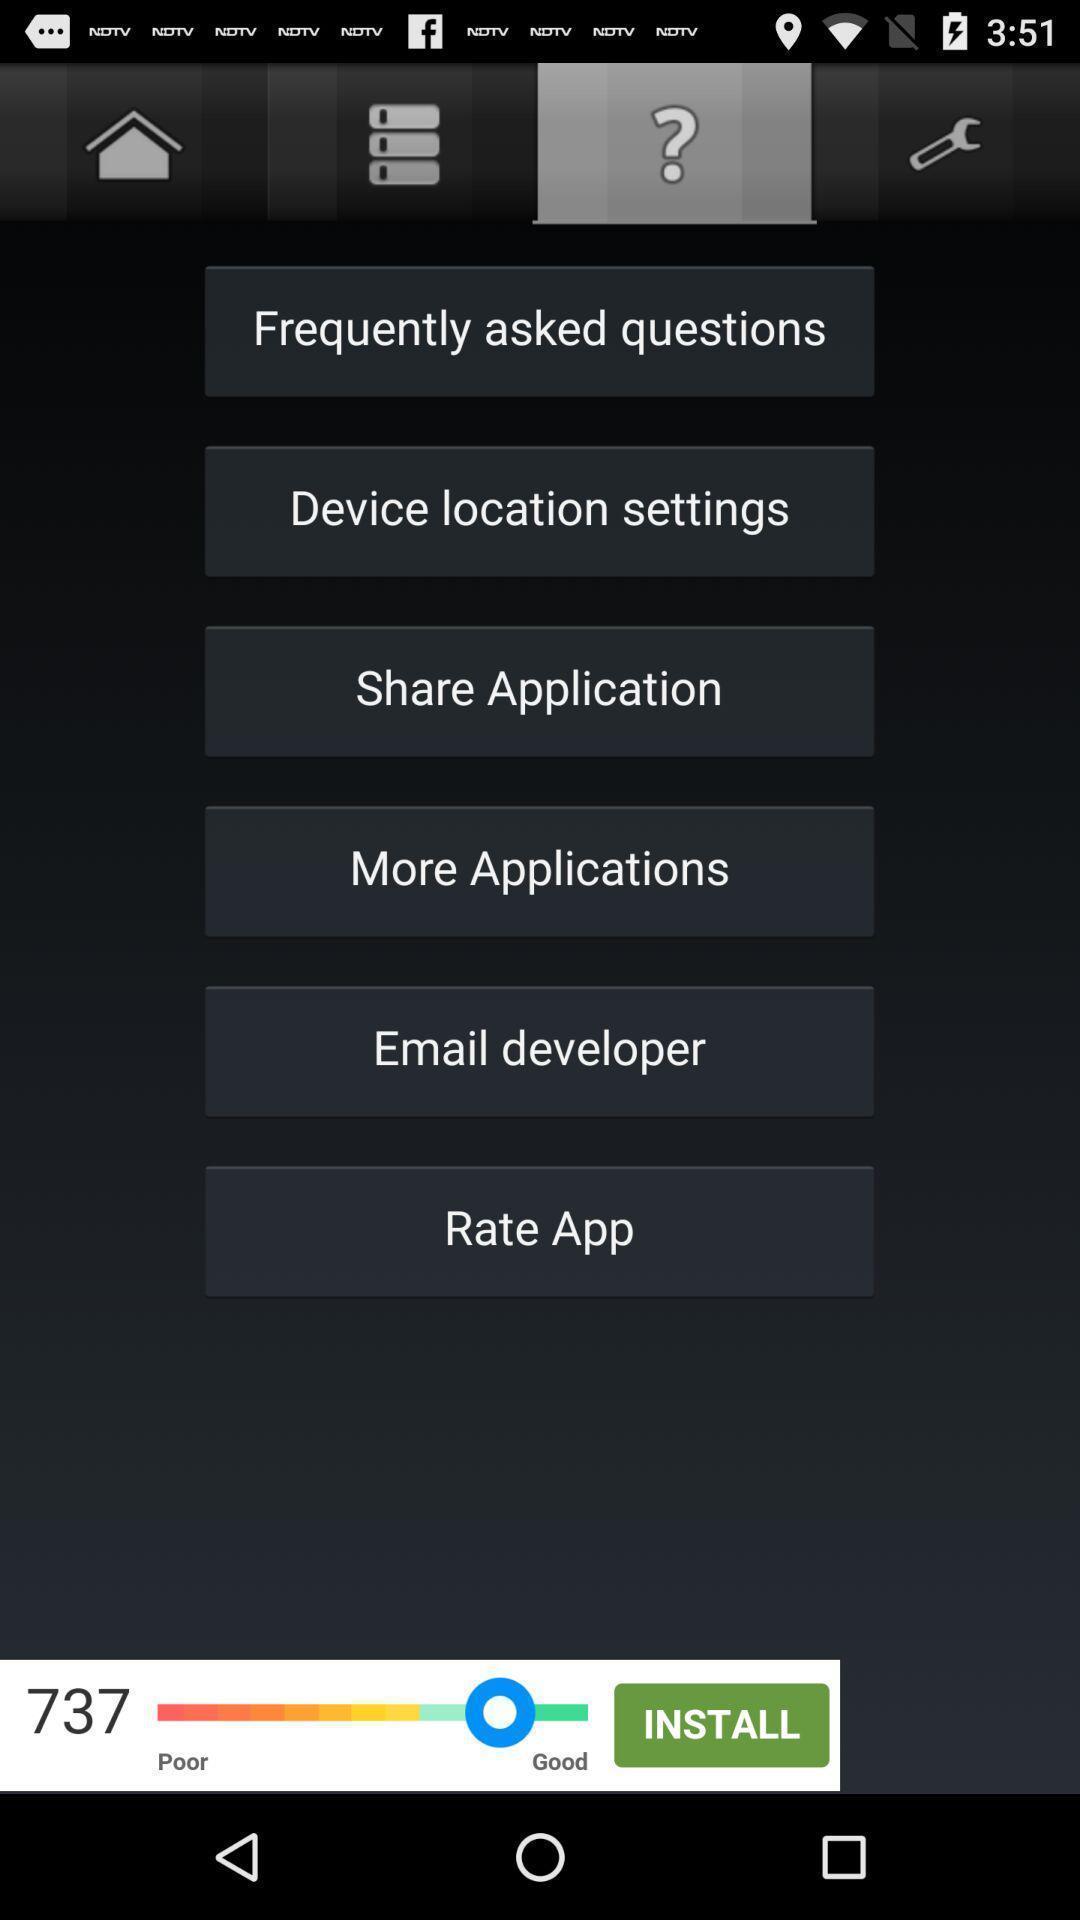Describe the content in this image. Screen shows various options. 